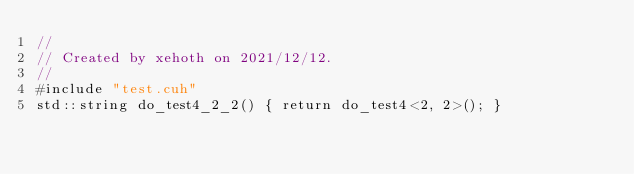<code> <loc_0><loc_0><loc_500><loc_500><_Cuda_>//
// Created by xehoth on 2021/12/12.
//
#include "test.cuh"
std::string do_test4_2_2() { return do_test4<2, 2>(); }
</code> 